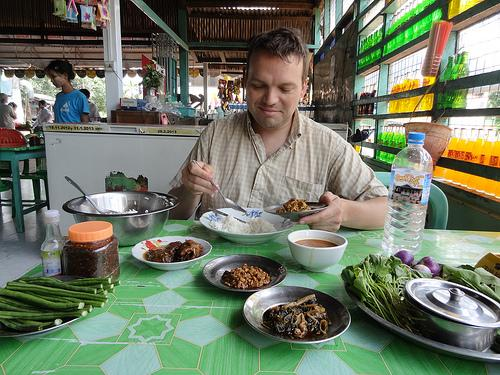Mention the color of the tablecloth and the theme of the served meal. The table is covered with a green and white tablecloth, and the meal appears to be a mixture of different dishes and flavors. Identify the central figure in the image and describe their appearance. The main subject is a man with dark brown hair wearing a plaid shirt, happily eating at a table filled with food. Mention one of the objects on the table that is not a dish and describe its appearance. There is a bottle of water with a blue cap placed on the table, next to the other dishes. Highlight the primary food item being consumed by the man in the image. The man is eating white rice from a blue and white bowl, holding a spoon in his hand. Describe the woman in the image and what she is wearing. There is a woman wearing a blue shirt, possibly at the same table as the man, but with less focus on her. State the type of table setting in the image and mention a specific drink item. The table is set for a dining experience with multiple food items and an orange drink in a glass bottle. Provide a brief overview of the scene presented in the image. A man is dining at a table full of assorted dishes, including a bowl of white rice, a plate of green vegetables, and a bottle of water on a green tablecloth. Describe the variety of food items visible on the table in the image. The table features green beans, white rice in a blue bowl, soup, meat, onions, and green leafy vegetables on a platter. Comment on the emotional state of the man in the image. The man appears to be happy and smiling, possibly enjoying the meal and the company around him. Describe the overall atmosphere and context of the scene in the image. The scene showcases a happy moment at a mealtime, with the man smiling and enjoying various food items on a vibrant dining table. 